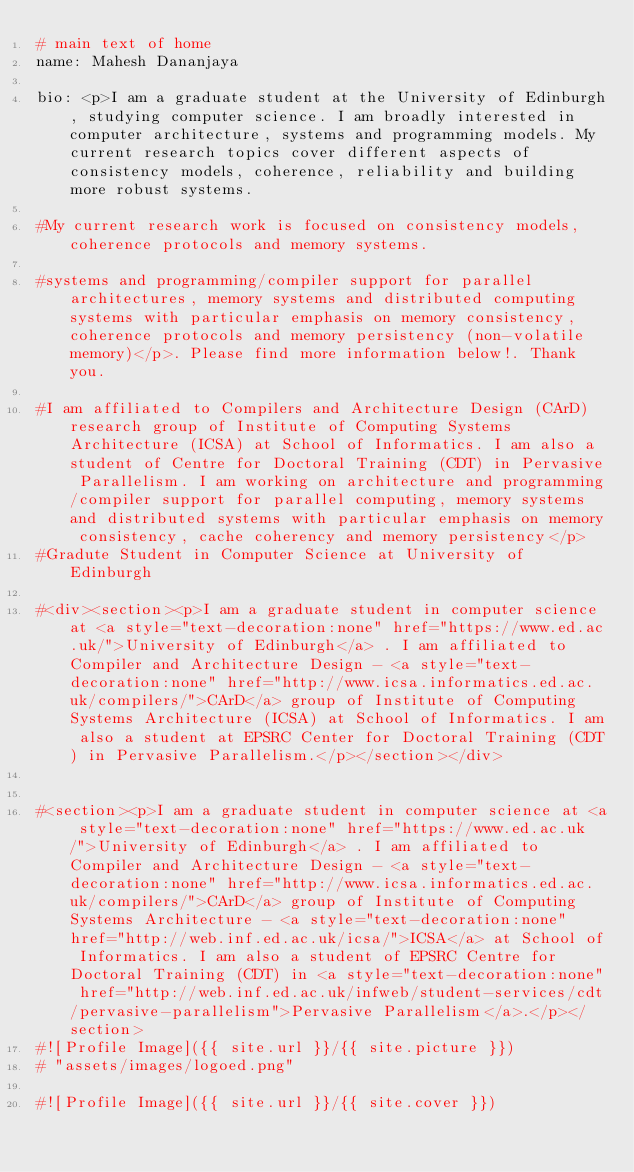Convert code to text. <code><loc_0><loc_0><loc_500><loc_500><_YAML_># main text of home
name: Mahesh Dananjaya

bio: <p>I am a graduate student at the University of Edinburgh, studying computer science. I am broadly interested in computer architecture, systems and programming models. My current research topics cover different aspects of consistency models, coherence, reliability and building more robust systems. 

#My current research work is focused on consistency models, coherence protocols and memory systems.

#systems and programming/compiler support for parallel architectures, memory systems and distributed computing systems with particular emphasis on memory consistency, coherence protocols and memory persistency (non-volatile memory)</p>. Please find more information below!. Thank you.

#I am affiliated to Compilers and Architecture Design (CArD) research group of Institute of Computing Systems Architecture (ICSA) at School of Informatics. I am also a student of Centre for Doctoral Training (CDT) in Pervasive Parallelism. I am working on architecture and programming/compiler support for parallel computing, memory systems and distributed systems with particular emphasis on memory consistency, cache coherency and memory persistency</p>
#Gradute Student in Computer Science at University of Edinburgh

#<div><section><p>I am a graduate student in computer science at <a style="text-decoration:none" href="https://www.ed.ac.uk/">University of Edinburgh</a> . I am affiliated to Compiler and Architecture Design - <a style="text-decoration:none" href="http://www.icsa.informatics.ed.ac.uk/compilers/">CArD</a> group of Institute of Computing Systems Architecture (ICSA) at School of Informatics. I am also a student at EPSRC Center for Doctoral Training (CDT) in Pervasive Parallelism.</p></section></div>


#<section><p>I am a graduate student in computer science at <a style="text-decoration:none" href="https://www.ed.ac.uk/">University of Edinburgh</a> . I am affiliated to Compiler and Architecture Design - <a style="text-decoration:none" href="http://www.icsa.informatics.ed.ac.uk/compilers/">CArD</a> group of Institute of Computing Systems Architecture - <a style="text-decoration:none" href="http://web.inf.ed.ac.uk/icsa/">ICSA</a> at School of Informatics. I am also a student of EPSRC Centre for Doctoral Training (CDT) in <a style="text-decoration:none" href="http://web.inf.ed.ac.uk/infweb/student-services/cdt/pervasive-parallelism">Pervasive Parallelism</a>.</p></section>
#![Profile Image]({{ site.url }}/{{ site.picture }})
# "assets/images/logoed.png"

#![Profile Image]({{ site.url }}/{{ site.cover }})
</code> 